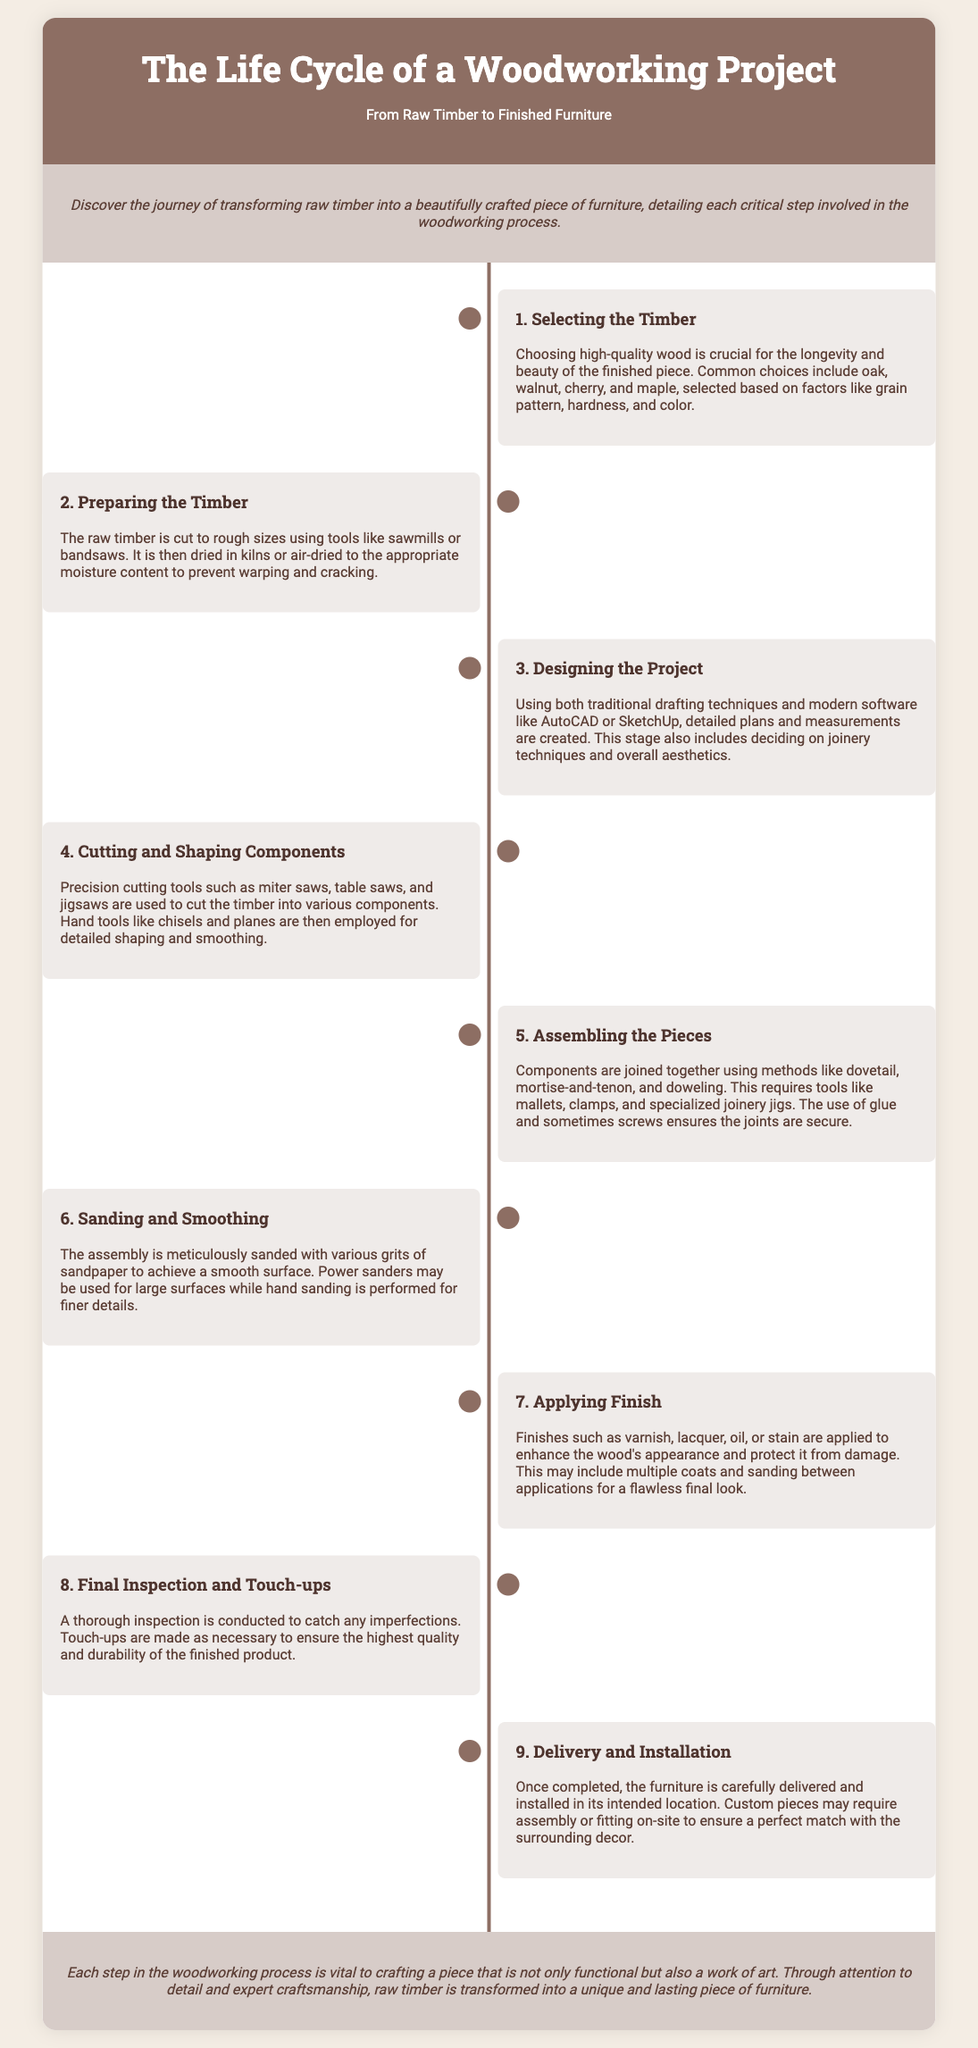What is the first step in the woodworking project? The first step in the woodworking project is selecting the timber, which is crucial for quality and beauty.
Answer: Selecting the Timber Which tool is used for detailed shaping and smoothing? Hand tools like chisels and planes are employed for detailed shaping and smoothing.
Answer: Chisels and planes What is applied to enhance the wood's appearance? Finishes such as varnish, lacquer, oil, or stain are applied to enhance the wood's appearance.
Answer: Finishes How many steps are there in the woodworking process? There are nine steps detailed in the woodworking process from raw timber to finished furniture.
Answer: Nine What is the purpose of sanding? Sanding is performed to achieve a smooth surface on the assembled items.
Answer: Achieve a smooth surface What types of wood are common choices for furniture? Common choices include oak, walnut, cherry, and maple, chosen based on specific characteristics.
Answer: Oak, walnut, cherry, maple Which stage includes deciding on joinery techniques? The designing stage includes deciding on joinery techniques and overall aesthetics.
Answer: Designing the Project What is the last step in the woodworking project? The last step in the woodworking project is delivery and installation.
Answer: Delivery and Installation 